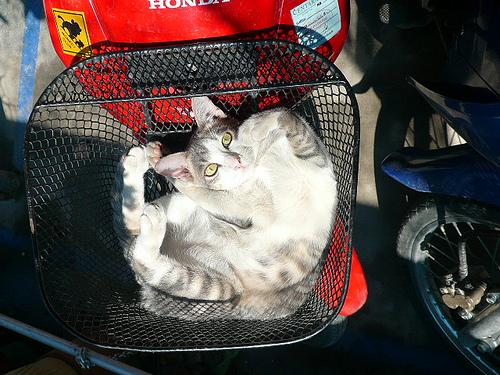Is this feline domesticated?
Write a very short answer. Yes. What is the cat inside of?
Quick response, please. Basket. Who is riding the bicycle?
Quick response, please. Cat. 